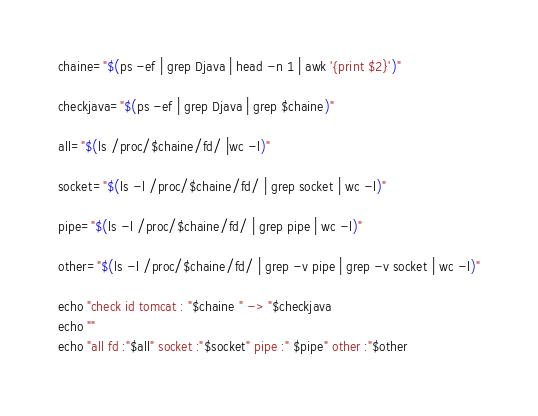Convert code to text. <code><loc_0><loc_0><loc_500><loc_500><_Bash_>
chaine="$(ps -ef | grep Djava | head -n 1 | awk '{print $2}')"

checkjava="$(ps -ef | grep Djava | grep $chaine)"

all="$(ls /proc/$chaine/fd/ |wc -l)"

socket="$(ls -l /proc/$chaine/fd/ | grep socket | wc -l)"

pipe="$(ls -l /proc/$chaine/fd/ | grep pipe | wc -l)"  

other="$(ls -l /proc/$chaine/fd/ | grep -v pipe | grep -v socket | wc -l)"

echo "check id tomcat : "$chaine " -> "$checkjava
echo ""
echo "all fd :"$all" socket :"$socket" pipe :" $pipe" other :"$other
</code> 